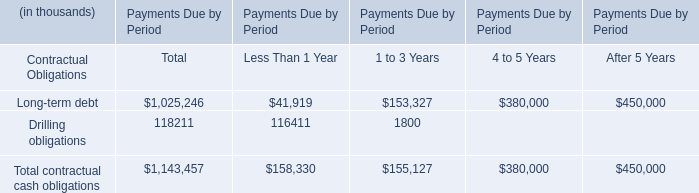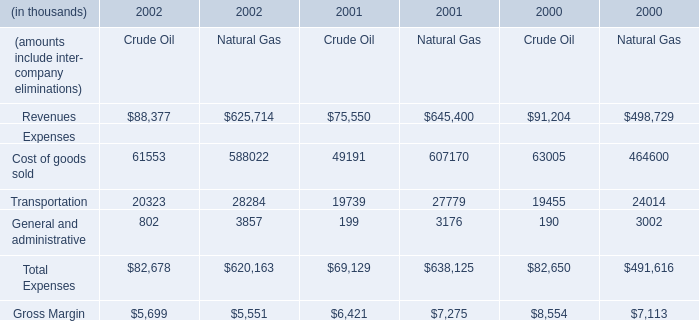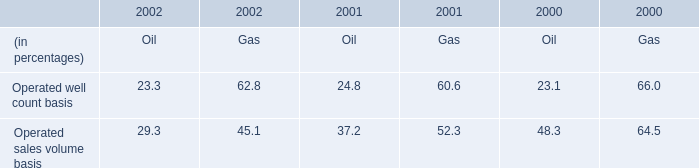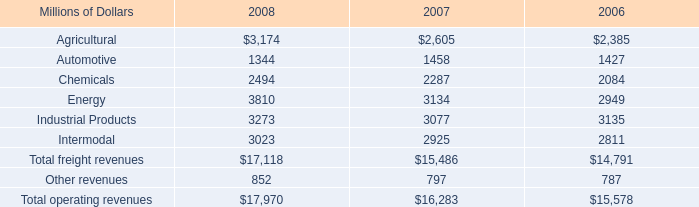What's the sum of Industrial Products of 2008, Transportation Expenses of 2001 Natural Gas, and Gross Margin Expenses of 2001 Crude Oil ? 
Computations: ((3273.0 + 27779.0) + 6421.0)
Answer: 37473.0. 